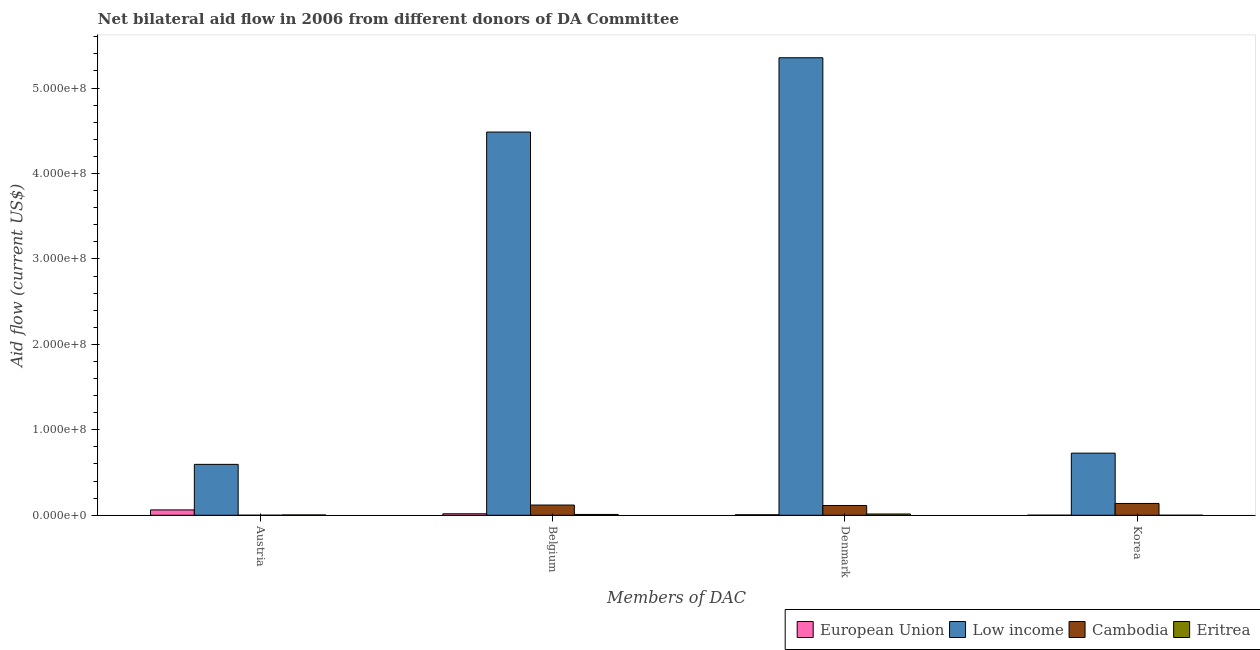Are the number of bars per tick equal to the number of legend labels?
Ensure brevity in your answer.  Yes. What is the label of the 4th group of bars from the left?
Keep it short and to the point. Korea. What is the amount of aid given by belgium in Eritrea?
Your answer should be compact. 9.50e+05. Across all countries, what is the maximum amount of aid given by denmark?
Provide a short and direct response. 5.35e+08. Across all countries, what is the minimum amount of aid given by austria?
Give a very brief answer. 2.00e+04. In which country was the amount of aid given by austria maximum?
Provide a short and direct response. Low income. In which country was the amount of aid given by korea minimum?
Your answer should be compact. Eritrea. What is the total amount of aid given by korea in the graph?
Give a very brief answer. 8.66e+07. What is the difference between the amount of aid given by belgium in Cambodia and that in Eritrea?
Offer a very short reply. 1.10e+07. What is the difference between the amount of aid given by korea in European Union and the amount of aid given by belgium in Cambodia?
Provide a short and direct response. -1.19e+07. What is the average amount of aid given by denmark per country?
Your response must be concise. 1.37e+08. What is the difference between the amount of aid given by austria and amount of aid given by denmark in Cambodia?
Give a very brief answer. -1.14e+07. In how many countries, is the amount of aid given by korea greater than 520000000 US$?
Give a very brief answer. 0. What is the ratio of the amount of aid given by denmark in Cambodia to that in Eritrea?
Give a very brief answer. 7.72. Is the amount of aid given by belgium in Cambodia less than that in Low income?
Give a very brief answer. Yes. Is the difference between the amount of aid given by korea in Low income and European Union greater than the difference between the amount of aid given by denmark in Low income and European Union?
Offer a terse response. No. What is the difference between the highest and the second highest amount of aid given by denmark?
Keep it short and to the point. 5.24e+08. What is the difference between the highest and the lowest amount of aid given by austria?
Make the answer very short. 5.95e+07. In how many countries, is the amount of aid given by belgium greater than the average amount of aid given by belgium taken over all countries?
Offer a very short reply. 1. Is the sum of the amount of aid given by belgium in Low income and European Union greater than the maximum amount of aid given by austria across all countries?
Your answer should be very brief. Yes. How many countries are there in the graph?
Provide a short and direct response. 4. Are the values on the major ticks of Y-axis written in scientific E-notation?
Make the answer very short. Yes. Does the graph contain grids?
Give a very brief answer. No. Where does the legend appear in the graph?
Ensure brevity in your answer.  Bottom right. How many legend labels are there?
Your response must be concise. 4. What is the title of the graph?
Your response must be concise. Net bilateral aid flow in 2006 from different donors of DA Committee. Does "Yemen, Rep." appear as one of the legend labels in the graph?
Provide a succinct answer. No. What is the label or title of the X-axis?
Offer a terse response. Members of DAC. What is the Aid flow (current US$) of European Union in Austria?
Your answer should be compact. 6.26e+06. What is the Aid flow (current US$) in Low income in Austria?
Provide a short and direct response. 5.96e+07. What is the Aid flow (current US$) of Cambodia in Austria?
Keep it short and to the point. 2.00e+04. What is the Aid flow (current US$) of European Union in Belgium?
Offer a terse response. 1.74e+06. What is the Aid flow (current US$) of Low income in Belgium?
Offer a very short reply. 4.48e+08. What is the Aid flow (current US$) in Cambodia in Belgium?
Give a very brief answer. 1.20e+07. What is the Aid flow (current US$) of Eritrea in Belgium?
Offer a terse response. 9.50e+05. What is the Aid flow (current US$) in European Union in Denmark?
Give a very brief answer. 5.80e+05. What is the Aid flow (current US$) of Low income in Denmark?
Provide a short and direct response. 5.35e+08. What is the Aid flow (current US$) of Cambodia in Denmark?
Make the answer very short. 1.14e+07. What is the Aid flow (current US$) in Eritrea in Denmark?
Give a very brief answer. 1.48e+06. What is the Aid flow (current US$) of Low income in Korea?
Your response must be concise. 7.27e+07. What is the Aid flow (current US$) of Cambodia in Korea?
Give a very brief answer. 1.38e+07. Across all Members of DAC, what is the maximum Aid flow (current US$) in European Union?
Your response must be concise. 6.26e+06. Across all Members of DAC, what is the maximum Aid flow (current US$) of Low income?
Your response must be concise. 5.35e+08. Across all Members of DAC, what is the maximum Aid flow (current US$) of Cambodia?
Your response must be concise. 1.38e+07. Across all Members of DAC, what is the maximum Aid flow (current US$) of Eritrea?
Provide a short and direct response. 1.48e+06. Across all Members of DAC, what is the minimum Aid flow (current US$) of Low income?
Your answer should be compact. 5.96e+07. What is the total Aid flow (current US$) of European Union in the graph?
Keep it short and to the point. 8.63e+06. What is the total Aid flow (current US$) of Low income in the graph?
Provide a succinct answer. 1.12e+09. What is the total Aid flow (current US$) of Cambodia in the graph?
Give a very brief answer. 3.72e+07. What is the total Aid flow (current US$) of Eritrea in the graph?
Make the answer very short. 2.80e+06. What is the difference between the Aid flow (current US$) of European Union in Austria and that in Belgium?
Ensure brevity in your answer.  4.52e+06. What is the difference between the Aid flow (current US$) of Low income in Austria and that in Belgium?
Your answer should be compact. -3.89e+08. What is the difference between the Aid flow (current US$) of Cambodia in Austria and that in Belgium?
Offer a terse response. -1.19e+07. What is the difference between the Aid flow (current US$) in Eritrea in Austria and that in Belgium?
Your answer should be very brief. -5.90e+05. What is the difference between the Aid flow (current US$) of European Union in Austria and that in Denmark?
Make the answer very short. 5.68e+06. What is the difference between the Aid flow (current US$) in Low income in Austria and that in Denmark?
Provide a succinct answer. -4.76e+08. What is the difference between the Aid flow (current US$) in Cambodia in Austria and that in Denmark?
Give a very brief answer. -1.14e+07. What is the difference between the Aid flow (current US$) in Eritrea in Austria and that in Denmark?
Keep it short and to the point. -1.12e+06. What is the difference between the Aid flow (current US$) in European Union in Austria and that in Korea?
Provide a short and direct response. 6.21e+06. What is the difference between the Aid flow (current US$) in Low income in Austria and that in Korea?
Keep it short and to the point. -1.31e+07. What is the difference between the Aid flow (current US$) of Cambodia in Austria and that in Korea?
Your response must be concise. -1.38e+07. What is the difference between the Aid flow (current US$) in European Union in Belgium and that in Denmark?
Ensure brevity in your answer.  1.16e+06. What is the difference between the Aid flow (current US$) of Low income in Belgium and that in Denmark?
Keep it short and to the point. -8.70e+07. What is the difference between the Aid flow (current US$) in Cambodia in Belgium and that in Denmark?
Offer a very short reply. 5.30e+05. What is the difference between the Aid flow (current US$) of Eritrea in Belgium and that in Denmark?
Your answer should be very brief. -5.30e+05. What is the difference between the Aid flow (current US$) of European Union in Belgium and that in Korea?
Your answer should be very brief. 1.69e+06. What is the difference between the Aid flow (current US$) of Low income in Belgium and that in Korea?
Ensure brevity in your answer.  3.76e+08. What is the difference between the Aid flow (current US$) of Cambodia in Belgium and that in Korea?
Offer a terse response. -1.87e+06. What is the difference between the Aid flow (current US$) in Eritrea in Belgium and that in Korea?
Provide a succinct answer. 9.40e+05. What is the difference between the Aid flow (current US$) in European Union in Denmark and that in Korea?
Your answer should be very brief. 5.30e+05. What is the difference between the Aid flow (current US$) of Low income in Denmark and that in Korea?
Provide a succinct answer. 4.63e+08. What is the difference between the Aid flow (current US$) of Cambodia in Denmark and that in Korea?
Your response must be concise. -2.40e+06. What is the difference between the Aid flow (current US$) in Eritrea in Denmark and that in Korea?
Keep it short and to the point. 1.47e+06. What is the difference between the Aid flow (current US$) of European Union in Austria and the Aid flow (current US$) of Low income in Belgium?
Keep it short and to the point. -4.42e+08. What is the difference between the Aid flow (current US$) in European Union in Austria and the Aid flow (current US$) in Cambodia in Belgium?
Your response must be concise. -5.70e+06. What is the difference between the Aid flow (current US$) of European Union in Austria and the Aid flow (current US$) of Eritrea in Belgium?
Make the answer very short. 5.31e+06. What is the difference between the Aid flow (current US$) of Low income in Austria and the Aid flow (current US$) of Cambodia in Belgium?
Provide a short and direct response. 4.76e+07. What is the difference between the Aid flow (current US$) in Low income in Austria and the Aid flow (current US$) in Eritrea in Belgium?
Provide a short and direct response. 5.86e+07. What is the difference between the Aid flow (current US$) of Cambodia in Austria and the Aid flow (current US$) of Eritrea in Belgium?
Give a very brief answer. -9.30e+05. What is the difference between the Aid flow (current US$) in European Union in Austria and the Aid flow (current US$) in Low income in Denmark?
Provide a succinct answer. -5.29e+08. What is the difference between the Aid flow (current US$) of European Union in Austria and the Aid flow (current US$) of Cambodia in Denmark?
Your response must be concise. -5.17e+06. What is the difference between the Aid flow (current US$) of European Union in Austria and the Aid flow (current US$) of Eritrea in Denmark?
Provide a succinct answer. 4.78e+06. What is the difference between the Aid flow (current US$) in Low income in Austria and the Aid flow (current US$) in Cambodia in Denmark?
Your response must be concise. 4.81e+07. What is the difference between the Aid flow (current US$) in Low income in Austria and the Aid flow (current US$) in Eritrea in Denmark?
Your answer should be compact. 5.81e+07. What is the difference between the Aid flow (current US$) of Cambodia in Austria and the Aid flow (current US$) of Eritrea in Denmark?
Provide a succinct answer. -1.46e+06. What is the difference between the Aid flow (current US$) of European Union in Austria and the Aid flow (current US$) of Low income in Korea?
Give a very brief answer. -6.64e+07. What is the difference between the Aid flow (current US$) of European Union in Austria and the Aid flow (current US$) of Cambodia in Korea?
Make the answer very short. -7.57e+06. What is the difference between the Aid flow (current US$) in European Union in Austria and the Aid flow (current US$) in Eritrea in Korea?
Offer a terse response. 6.25e+06. What is the difference between the Aid flow (current US$) of Low income in Austria and the Aid flow (current US$) of Cambodia in Korea?
Ensure brevity in your answer.  4.57e+07. What is the difference between the Aid flow (current US$) in Low income in Austria and the Aid flow (current US$) in Eritrea in Korea?
Your response must be concise. 5.96e+07. What is the difference between the Aid flow (current US$) in European Union in Belgium and the Aid flow (current US$) in Low income in Denmark?
Your response must be concise. -5.34e+08. What is the difference between the Aid flow (current US$) of European Union in Belgium and the Aid flow (current US$) of Cambodia in Denmark?
Give a very brief answer. -9.69e+06. What is the difference between the Aid flow (current US$) of European Union in Belgium and the Aid flow (current US$) of Eritrea in Denmark?
Provide a succinct answer. 2.60e+05. What is the difference between the Aid flow (current US$) of Low income in Belgium and the Aid flow (current US$) of Cambodia in Denmark?
Give a very brief answer. 4.37e+08. What is the difference between the Aid flow (current US$) of Low income in Belgium and the Aid flow (current US$) of Eritrea in Denmark?
Ensure brevity in your answer.  4.47e+08. What is the difference between the Aid flow (current US$) in Cambodia in Belgium and the Aid flow (current US$) in Eritrea in Denmark?
Provide a short and direct response. 1.05e+07. What is the difference between the Aid flow (current US$) of European Union in Belgium and the Aid flow (current US$) of Low income in Korea?
Make the answer very short. -7.10e+07. What is the difference between the Aid flow (current US$) in European Union in Belgium and the Aid flow (current US$) in Cambodia in Korea?
Make the answer very short. -1.21e+07. What is the difference between the Aid flow (current US$) of European Union in Belgium and the Aid flow (current US$) of Eritrea in Korea?
Provide a succinct answer. 1.73e+06. What is the difference between the Aid flow (current US$) in Low income in Belgium and the Aid flow (current US$) in Cambodia in Korea?
Give a very brief answer. 4.35e+08. What is the difference between the Aid flow (current US$) in Low income in Belgium and the Aid flow (current US$) in Eritrea in Korea?
Make the answer very short. 4.48e+08. What is the difference between the Aid flow (current US$) in Cambodia in Belgium and the Aid flow (current US$) in Eritrea in Korea?
Provide a short and direct response. 1.20e+07. What is the difference between the Aid flow (current US$) of European Union in Denmark and the Aid flow (current US$) of Low income in Korea?
Your answer should be very brief. -7.21e+07. What is the difference between the Aid flow (current US$) in European Union in Denmark and the Aid flow (current US$) in Cambodia in Korea?
Your answer should be very brief. -1.32e+07. What is the difference between the Aid flow (current US$) in European Union in Denmark and the Aid flow (current US$) in Eritrea in Korea?
Your answer should be very brief. 5.70e+05. What is the difference between the Aid flow (current US$) of Low income in Denmark and the Aid flow (current US$) of Cambodia in Korea?
Offer a terse response. 5.22e+08. What is the difference between the Aid flow (current US$) in Low income in Denmark and the Aid flow (current US$) in Eritrea in Korea?
Provide a succinct answer. 5.35e+08. What is the difference between the Aid flow (current US$) in Cambodia in Denmark and the Aid flow (current US$) in Eritrea in Korea?
Your response must be concise. 1.14e+07. What is the average Aid flow (current US$) of European Union per Members of DAC?
Make the answer very short. 2.16e+06. What is the average Aid flow (current US$) in Low income per Members of DAC?
Your answer should be compact. 2.79e+08. What is the average Aid flow (current US$) of Cambodia per Members of DAC?
Your response must be concise. 9.31e+06. What is the difference between the Aid flow (current US$) of European Union and Aid flow (current US$) of Low income in Austria?
Offer a very short reply. -5.33e+07. What is the difference between the Aid flow (current US$) in European Union and Aid flow (current US$) in Cambodia in Austria?
Give a very brief answer. 6.24e+06. What is the difference between the Aid flow (current US$) of European Union and Aid flow (current US$) of Eritrea in Austria?
Your response must be concise. 5.90e+06. What is the difference between the Aid flow (current US$) in Low income and Aid flow (current US$) in Cambodia in Austria?
Your response must be concise. 5.95e+07. What is the difference between the Aid flow (current US$) in Low income and Aid flow (current US$) in Eritrea in Austria?
Give a very brief answer. 5.92e+07. What is the difference between the Aid flow (current US$) of European Union and Aid flow (current US$) of Low income in Belgium?
Your answer should be compact. -4.47e+08. What is the difference between the Aid flow (current US$) of European Union and Aid flow (current US$) of Cambodia in Belgium?
Ensure brevity in your answer.  -1.02e+07. What is the difference between the Aid flow (current US$) in European Union and Aid flow (current US$) in Eritrea in Belgium?
Provide a succinct answer. 7.90e+05. What is the difference between the Aid flow (current US$) in Low income and Aid flow (current US$) in Cambodia in Belgium?
Ensure brevity in your answer.  4.37e+08. What is the difference between the Aid flow (current US$) of Low income and Aid flow (current US$) of Eritrea in Belgium?
Offer a very short reply. 4.48e+08. What is the difference between the Aid flow (current US$) in Cambodia and Aid flow (current US$) in Eritrea in Belgium?
Offer a very short reply. 1.10e+07. What is the difference between the Aid flow (current US$) of European Union and Aid flow (current US$) of Low income in Denmark?
Give a very brief answer. -5.35e+08. What is the difference between the Aid flow (current US$) of European Union and Aid flow (current US$) of Cambodia in Denmark?
Keep it short and to the point. -1.08e+07. What is the difference between the Aid flow (current US$) of European Union and Aid flow (current US$) of Eritrea in Denmark?
Give a very brief answer. -9.00e+05. What is the difference between the Aid flow (current US$) of Low income and Aid flow (current US$) of Cambodia in Denmark?
Your response must be concise. 5.24e+08. What is the difference between the Aid flow (current US$) of Low income and Aid flow (current US$) of Eritrea in Denmark?
Ensure brevity in your answer.  5.34e+08. What is the difference between the Aid flow (current US$) of Cambodia and Aid flow (current US$) of Eritrea in Denmark?
Your answer should be compact. 9.95e+06. What is the difference between the Aid flow (current US$) in European Union and Aid flow (current US$) in Low income in Korea?
Your response must be concise. -7.26e+07. What is the difference between the Aid flow (current US$) of European Union and Aid flow (current US$) of Cambodia in Korea?
Your response must be concise. -1.38e+07. What is the difference between the Aid flow (current US$) in European Union and Aid flow (current US$) in Eritrea in Korea?
Provide a short and direct response. 4.00e+04. What is the difference between the Aid flow (current US$) of Low income and Aid flow (current US$) of Cambodia in Korea?
Give a very brief answer. 5.89e+07. What is the difference between the Aid flow (current US$) of Low income and Aid flow (current US$) of Eritrea in Korea?
Make the answer very short. 7.27e+07. What is the difference between the Aid flow (current US$) in Cambodia and Aid flow (current US$) in Eritrea in Korea?
Your answer should be very brief. 1.38e+07. What is the ratio of the Aid flow (current US$) of European Union in Austria to that in Belgium?
Ensure brevity in your answer.  3.6. What is the ratio of the Aid flow (current US$) of Low income in Austria to that in Belgium?
Make the answer very short. 0.13. What is the ratio of the Aid flow (current US$) in Cambodia in Austria to that in Belgium?
Offer a terse response. 0. What is the ratio of the Aid flow (current US$) in Eritrea in Austria to that in Belgium?
Your answer should be very brief. 0.38. What is the ratio of the Aid flow (current US$) in European Union in Austria to that in Denmark?
Offer a terse response. 10.79. What is the ratio of the Aid flow (current US$) in Low income in Austria to that in Denmark?
Give a very brief answer. 0.11. What is the ratio of the Aid flow (current US$) of Cambodia in Austria to that in Denmark?
Your answer should be very brief. 0. What is the ratio of the Aid flow (current US$) of Eritrea in Austria to that in Denmark?
Provide a short and direct response. 0.24. What is the ratio of the Aid flow (current US$) of European Union in Austria to that in Korea?
Offer a very short reply. 125.2. What is the ratio of the Aid flow (current US$) of Low income in Austria to that in Korea?
Provide a succinct answer. 0.82. What is the ratio of the Aid flow (current US$) of Cambodia in Austria to that in Korea?
Ensure brevity in your answer.  0. What is the ratio of the Aid flow (current US$) in Eritrea in Austria to that in Korea?
Give a very brief answer. 36. What is the ratio of the Aid flow (current US$) of European Union in Belgium to that in Denmark?
Provide a succinct answer. 3. What is the ratio of the Aid flow (current US$) in Low income in Belgium to that in Denmark?
Provide a short and direct response. 0.84. What is the ratio of the Aid flow (current US$) of Cambodia in Belgium to that in Denmark?
Make the answer very short. 1.05. What is the ratio of the Aid flow (current US$) of Eritrea in Belgium to that in Denmark?
Your answer should be very brief. 0.64. What is the ratio of the Aid flow (current US$) in European Union in Belgium to that in Korea?
Keep it short and to the point. 34.8. What is the ratio of the Aid flow (current US$) of Low income in Belgium to that in Korea?
Keep it short and to the point. 6.17. What is the ratio of the Aid flow (current US$) in Cambodia in Belgium to that in Korea?
Provide a succinct answer. 0.86. What is the ratio of the Aid flow (current US$) of European Union in Denmark to that in Korea?
Your answer should be very brief. 11.6. What is the ratio of the Aid flow (current US$) of Low income in Denmark to that in Korea?
Your response must be concise. 7.37. What is the ratio of the Aid flow (current US$) in Cambodia in Denmark to that in Korea?
Your answer should be compact. 0.83. What is the ratio of the Aid flow (current US$) in Eritrea in Denmark to that in Korea?
Your answer should be very brief. 148. What is the difference between the highest and the second highest Aid flow (current US$) of European Union?
Provide a succinct answer. 4.52e+06. What is the difference between the highest and the second highest Aid flow (current US$) in Low income?
Provide a short and direct response. 8.70e+07. What is the difference between the highest and the second highest Aid flow (current US$) in Cambodia?
Your answer should be compact. 1.87e+06. What is the difference between the highest and the second highest Aid flow (current US$) in Eritrea?
Your answer should be compact. 5.30e+05. What is the difference between the highest and the lowest Aid flow (current US$) of European Union?
Ensure brevity in your answer.  6.21e+06. What is the difference between the highest and the lowest Aid flow (current US$) in Low income?
Offer a very short reply. 4.76e+08. What is the difference between the highest and the lowest Aid flow (current US$) in Cambodia?
Your answer should be compact. 1.38e+07. What is the difference between the highest and the lowest Aid flow (current US$) in Eritrea?
Keep it short and to the point. 1.47e+06. 